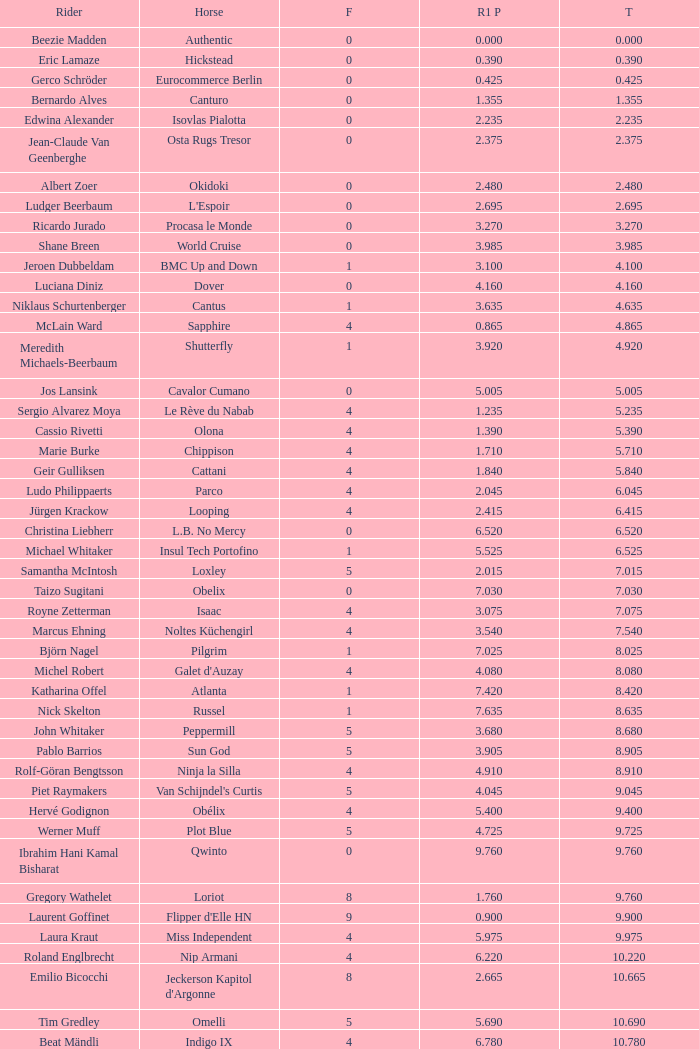Tell me the most total for horse of carlson 29.545. 